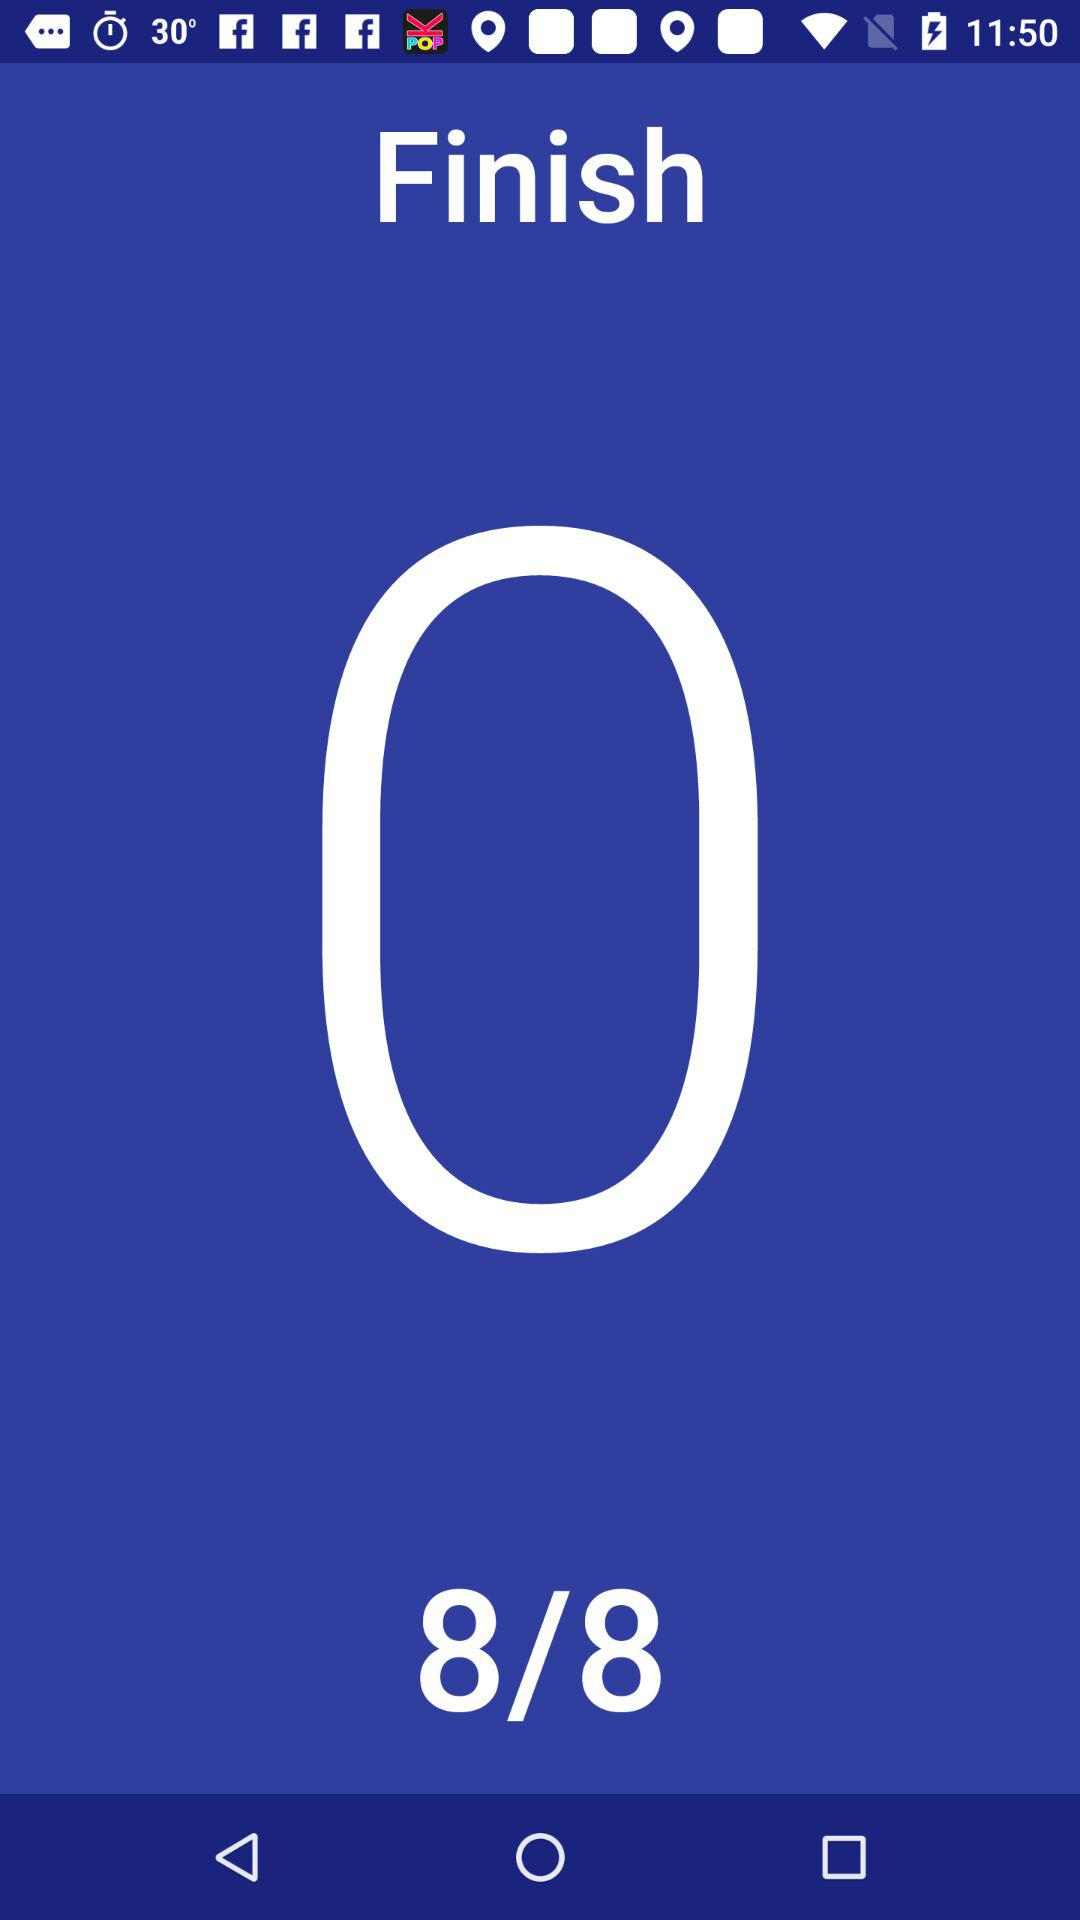What is the given total number of steps? The total number of steps is 8. 